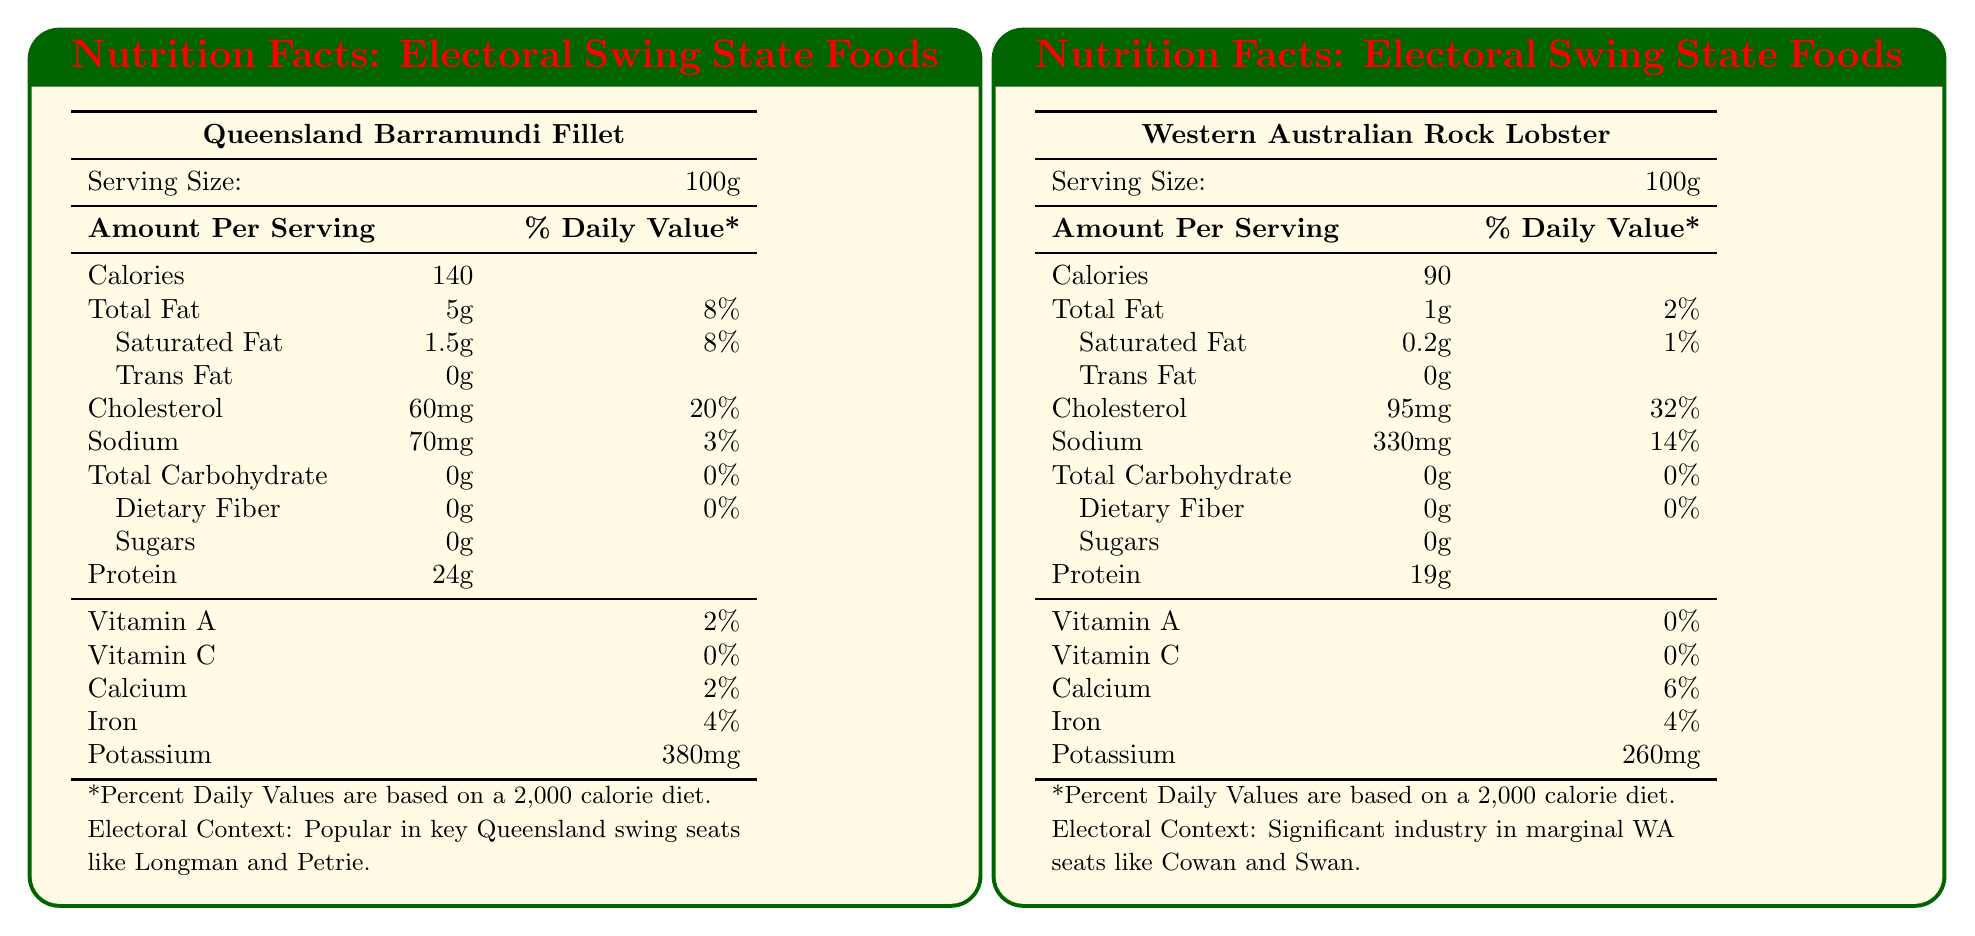where is Queensland Barramundi Fillet popular? The document lists the electoral context for Queensland Barramundi Fillet, mentioning its popularity in seats such as Longman and Petrie.
Answer: Key Queensland swing seats like Longman and Petrie how many milligrams of potassium does South Australian King George Whiting have per serving? The document states that South Australian King George Whiting contains 350 mg of potassium per serving.
Answer: 350 mg which food has the highest amount of cholesterol per serving? The Western Australian Rock Lobster has 95 mg of cholesterol per serving, which is higher than any other food listed in the document.
Answer: Western Australian Rock Lobster compare the amount of protein in Queensland Barramundi Fillet and South Australian King George Whiting. Queensland Barramundi Fillet contains 24 grams of protein, while South Australian King George Whiting contains 21 grams.
Answer: Queensland Barramundi Fillet has 24g, South Australian King George Whiting has 21g what is the serving size for New South Wales Hunter Valley Shiraz? The document specifies that the serving size for New South Wales Hunter Valley Shiraz is 150ml.
Answer: 150ml which food contains the most calories per serving? A. Queensland Barramundi Fillet B. Western Australian Rock Lobster C. Tasmanian Leatherwood Honey Queensland Barramundi Fillet contains 140 calories per serving, which is the highest among the options provided.
Answer: A how much calcium does the Western Australian Rock Lobster provide per serving? The document indicates that Western Australian Rock Lobster provides 6% of the daily value for calcium per serving.
Answer: 6% of the daily value is the Tasmanian Leatherwood Honey produced in the marginal seats of Tasmania? The document notes that the Tasmanian Leatherwood Honey is produced in the historically volatile electorate of Braddon, but it does not specifically mention marginal seats.
Answer: No does South Australian King George Whiting contain any trans fat? The document lists the amount of trans fat in South Australian King George Whiting as 0g.
Answer: No describe the main idea of the document. The document details the nutrient profiles for a variety of traditional Australian foods popular in key electoral swing states, such as Queensland Barramundi Fillet and Western Australian Rock Lobster, and includes information on serving size, calorie count, fat content, and more. It also mentions the electoral context where each food is significant.
Answer: The document provides nutritional facts for traditional foods associated with key electoral swing states in Australia, highlighting their nutrient content and electoral context. why is Tasmanian Leatherwood Honey important in electoral terms? The document only mentions that Tasmanian Leatherwood Honey is produced in the historically volatile electorate of Braddon, but it does not explain why it is important or the specific electoral significance.
Answer: Not enough information 